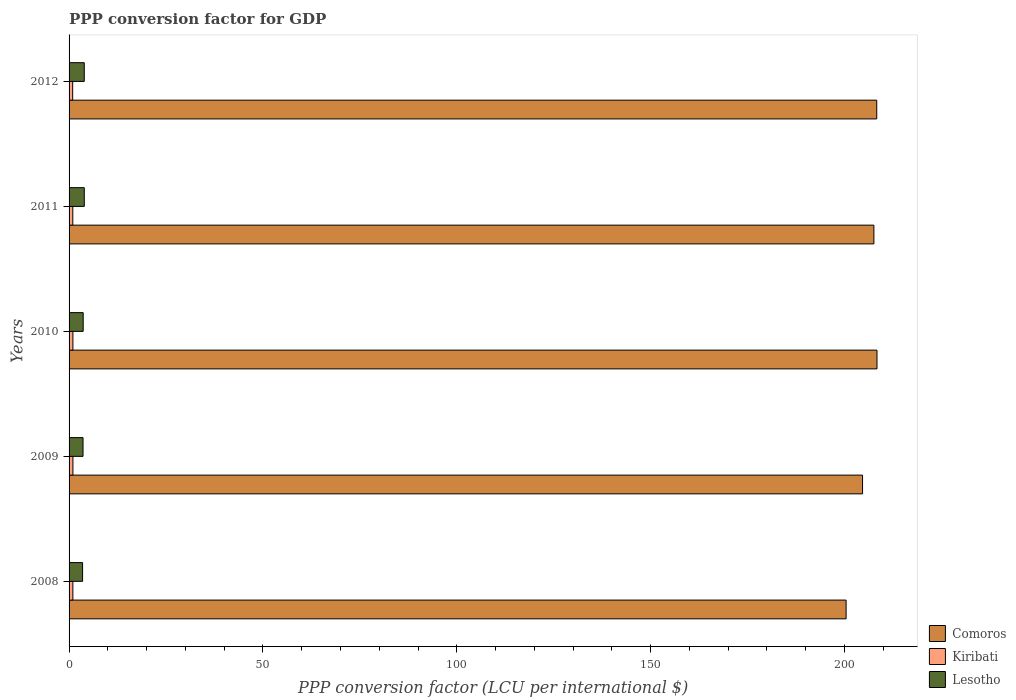How many different coloured bars are there?
Your response must be concise. 3. How many groups of bars are there?
Make the answer very short. 5. Are the number of bars per tick equal to the number of legend labels?
Ensure brevity in your answer.  Yes. Are the number of bars on each tick of the Y-axis equal?
Offer a very short reply. Yes. How many bars are there on the 4th tick from the top?
Offer a very short reply. 3. How many bars are there on the 4th tick from the bottom?
Offer a terse response. 3. What is the PPP conversion factor for GDP in Kiribati in 2010?
Provide a succinct answer. 0.99. Across all years, what is the maximum PPP conversion factor for GDP in Kiribati?
Offer a very short reply. 0.99. Across all years, what is the minimum PPP conversion factor for GDP in Comoros?
Offer a terse response. 200.42. What is the total PPP conversion factor for GDP in Kiribati in the graph?
Your answer should be compact. 4.85. What is the difference between the PPP conversion factor for GDP in Kiribati in 2009 and that in 2010?
Give a very brief answer. 0. What is the difference between the PPP conversion factor for GDP in Lesotho in 2010 and the PPP conversion factor for GDP in Comoros in 2011?
Your response must be concise. -203.94. What is the average PPP conversion factor for GDP in Comoros per year?
Your response must be concise. 205.87. In the year 2011, what is the difference between the PPP conversion factor for GDP in Comoros and PPP conversion factor for GDP in Lesotho?
Ensure brevity in your answer.  203.66. In how many years, is the PPP conversion factor for GDP in Lesotho greater than 100 LCU?
Ensure brevity in your answer.  0. What is the ratio of the PPP conversion factor for GDP in Lesotho in 2008 to that in 2009?
Offer a terse response. 0.97. Is the PPP conversion factor for GDP in Comoros in 2010 less than that in 2012?
Offer a very short reply. No. Is the difference between the PPP conversion factor for GDP in Comoros in 2008 and 2011 greater than the difference between the PPP conversion factor for GDP in Lesotho in 2008 and 2011?
Ensure brevity in your answer.  No. What is the difference between the highest and the second highest PPP conversion factor for GDP in Kiribati?
Offer a terse response. 0. What is the difference between the highest and the lowest PPP conversion factor for GDP in Kiribati?
Give a very brief answer. 0.06. Is the sum of the PPP conversion factor for GDP in Comoros in 2008 and 2011 greater than the maximum PPP conversion factor for GDP in Kiribati across all years?
Offer a very short reply. Yes. What does the 3rd bar from the top in 2009 represents?
Ensure brevity in your answer.  Comoros. What does the 2nd bar from the bottom in 2008 represents?
Provide a succinct answer. Kiribati. Is it the case that in every year, the sum of the PPP conversion factor for GDP in Lesotho and PPP conversion factor for GDP in Comoros is greater than the PPP conversion factor for GDP in Kiribati?
Provide a short and direct response. Yes. Are all the bars in the graph horizontal?
Offer a terse response. Yes. What is the difference between two consecutive major ticks on the X-axis?
Offer a terse response. 50. Where does the legend appear in the graph?
Your answer should be very brief. Bottom right. How are the legend labels stacked?
Give a very brief answer. Vertical. What is the title of the graph?
Provide a short and direct response. PPP conversion factor for GDP. Does "South Africa" appear as one of the legend labels in the graph?
Your answer should be very brief. No. What is the label or title of the X-axis?
Give a very brief answer. PPP conversion factor (LCU per international $). What is the PPP conversion factor (LCU per international $) of Comoros in 2008?
Provide a succinct answer. 200.42. What is the PPP conversion factor (LCU per international $) of Kiribati in 2008?
Your response must be concise. 0.98. What is the PPP conversion factor (LCU per international $) of Lesotho in 2008?
Provide a short and direct response. 3.48. What is the PPP conversion factor (LCU per international $) of Comoros in 2009?
Offer a very short reply. 204.66. What is the PPP conversion factor (LCU per international $) of Kiribati in 2009?
Your answer should be compact. 0.99. What is the PPP conversion factor (LCU per international $) in Lesotho in 2009?
Make the answer very short. 3.6. What is the PPP conversion factor (LCU per international $) of Comoros in 2010?
Your response must be concise. 208.39. What is the PPP conversion factor (LCU per international $) in Kiribati in 2010?
Make the answer very short. 0.99. What is the PPP conversion factor (LCU per international $) in Lesotho in 2010?
Your answer should be compact. 3.64. What is the PPP conversion factor (LCU per international $) in Comoros in 2011?
Your answer should be compact. 207.58. What is the PPP conversion factor (LCU per international $) in Kiribati in 2011?
Give a very brief answer. 0.96. What is the PPP conversion factor (LCU per international $) in Lesotho in 2011?
Give a very brief answer. 3.92. What is the PPP conversion factor (LCU per international $) in Comoros in 2012?
Give a very brief answer. 208.32. What is the PPP conversion factor (LCU per international $) of Kiribati in 2012?
Your response must be concise. 0.93. What is the PPP conversion factor (LCU per international $) of Lesotho in 2012?
Offer a very short reply. 3.92. Across all years, what is the maximum PPP conversion factor (LCU per international $) of Comoros?
Offer a terse response. 208.39. Across all years, what is the maximum PPP conversion factor (LCU per international $) of Kiribati?
Make the answer very short. 0.99. Across all years, what is the maximum PPP conversion factor (LCU per international $) of Lesotho?
Ensure brevity in your answer.  3.92. Across all years, what is the minimum PPP conversion factor (LCU per international $) of Comoros?
Your response must be concise. 200.42. Across all years, what is the minimum PPP conversion factor (LCU per international $) of Kiribati?
Give a very brief answer. 0.93. Across all years, what is the minimum PPP conversion factor (LCU per international $) of Lesotho?
Your answer should be very brief. 3.48. What is the total PPP conversion factor (LCU per international $) in Comoros in the graph?
Offer a terse response. 1029.37. What is the total PPP conversion factor (LCU per international $) in Kiribati in the graph?
Offer a very short reply. 4.85. What is the total PPP conversion factor (LCU per international $) in Lesotho in the graph?
Offer a very short reply. 18.57. What is the difference between the PPP conversion factor (LCU per international $) of Comoros in 2008 and that in 2009?
Give a very brief answer. -4.24. What is the difference between the PPP conversion factor (LCU per international $) of Kiribati in 2008 and that in 2009?
Provide a short and direct response. -0.01. What is the difference between the PPP conversion factor (LCU per international $) of Lesotho in 2008 and that in 2009?
Your answer should be very brief. -0.12. What is the difference between the PPP conversion factor (LCU per international $) in Comoros in 2008 and that in 2010?
Your answer should be very brief. -7.97. What is the difference between the PPP conversion factor (LCU per international $) of Kiribati in 2008 and that in 2010?
Ensure brevity in your answer.  -0.01. What is the difference between the PPP conversion factor (LCU per international $) in Lesotho in 2008 and that in 2010?
Your response must be concise. -0.16. What is the difference between the PPP conversion factor (LCU per international $) of Comoros in 2008 and that in 2011?
Your answer should be compact. -7.16. What is the difference between the PPP conversion factor (LCU per international $) of Kiribati in 2008 and that in 2011?
Provide a succinct answer. 0.02. What is the difference between the PPP conversion factor (LCU per international $) in Lesotho in 2008 and that in 2011?
Provide a short and direct response. -0.44. What is the difference between the PPP conversion factor (LCU per international $) in Comoros in 2008 and that in 2012?
Offer a terse response. -7.9. What is the difference between the PPP conversion factor (LCU per international $) in Kiribati in 2008 and that in 2012?
Keep it short and to the point. 0.05. What is the difference between the PPP conversion factor (LCU per international $) in Lesotho in 2008 and that in 2012?
Offer a very short reply. -0.44. What is the difference between the PPP conversion factor (LCU per international $) in Comoros in 2009 and that in 2010?
Your response must be concise. -3.73. What is the difference between the PPP conversion factor (LCU per international $) in Kiribati in 2009 and that in 2010?
Offer a terse response. 0. What is the difference between the PPP conversion factor (LCU per international $) in Lesotho in 2009 and that in 2010?
Ensure brevity in your answer.  -0.04. What is the difference between the PPP conversion factor (LCU per international $) in Comoros in 2009 and that in 2011?
Your response must be concise. -2.93. What is the difference between the PPP conversion factor (LCU per international $) of Kiribati in 2009 and that in 2011?
Your answer should be compact. 0.03. What is the difference between the PPP conversion factor (LCU per international $) in Lesotho in 2009 and that in 2011?
Provide a short and direct response. -0.32. What is the difference between the PPP conversion factor (LCU per international $) in Comoros in 2009 and that in 2012?
Give a very brief answer. -3.66. What is the difference between the PPP conversion factor (LCU per international $) in Kiribati in 2009 and that in 2012?
Keep it short and to the point. 0.06. What is the difference between the PPP conversion factor (LCU per international $) of Lesotho in 2009 and that in 2012?
Provide a succinct answer. -0.32. What is the difference between the PPP conversion factor (LCU per international $) of Comoros in 2010 and that in 2011?
Offer a very short reply. 0.8. What is the difference between the PPP conversion factor (LCU per international $) in Kiribati in 2010 and that in 2011?
Your answer should be very brief. 0.03. What is the difference between the PPP conversion factor (LCU per international $) in Lesotho in 2010 and that in 2011?
Offer a terse response. -0.28. What is the difference between the PPP conversion factor (LCU per international $) of Comoros in 2010 and that in 2012?
Give a very brief answer. 0.07. What is the difference between the PPP conversion factor (LCU per international $) in Kiribati in 2010 and that in 2012?
Your response must be concise. 0.06. What is the difference between the PPP conversion factor (LCU per international $) in Lesotho in 2010 and that in 2012?
Keep it short and to the point. -0.28. What is the difference between the PPP conversion factor (LCU per international $) of Comoros in 2011 and that in 2012?
Keep it short and to the point. -0.74. What is the difference between the PPP conversion factor (LCU per international $) of Kiribati in 2011 and that in 2012?
Offer a terse response. 0.03. What is the difference between the PPP conversion factor (LCU per international $) in Lesotho in 2011 and that in 2012?
Give a very brief answer. 0. What is the difference between the PPP conversion factor (LCU per international $) in Comoros in 2008 and the PPP conversion factor (LCU per international $) in Kiribati in 2009?
Offer a very short reply. 199.43. What is the difference between the PPP conversion factor (LCU per international $) in Comoros in 2008 and the PPP conversion factor (LCU per international $) in Lesotho in 2009?
Give a very brief answer. 196.82. What is the difference between the PPP conversion factor (LCU per international $) of Kiribati in 2008 and the PPP conversion factor (LCU per international $) of Lesotho in 2009?
Your answer should be compact. -2.62. What is the difference between the PPP conversion factor (LCU per international $) in Comoros in 2008 and the PPP conversion factor (LCU per international $) in Kiribati in 2010?
Give a very brief answer. 199.43. What is the difference between the PPP conversion factor (LCU per international $) of Comoros in 2008 and the PPP conversion factor (LCU per international $) of Lesotho in 2010?
Provide a succinct answer. 196.78. What is the difference between the PPP conversion factor (LCU per international $) in Kiribati in 2008 and the PPP conversion factor (LCU per international $) in Lesotho in 2010?
Your answer should be compact. -2.66. What is the difference between the PPP conversion factor (LCU per international $) in Comoros in 2008 and the PPP conversion factor (LCU per international $) in Kiribati in 2011?
Your response must be concise. 199.46. What is the difference between the PPP conversion factor (LCU per international $) in Comoros in 2008 and the PPP conversion factor (LCU per international $) in Lesotho in 2011?
Make the answer very short. 196.5. What is the difference between the PPP conversion factor (LCU per international $) of Kiribati in 2008 and the PPP conversion factor (LCU per international $) of Lesotho in 2011?
Make the answer very short. -2.94. What is the difference between the PPP conversion factor (LCU per international $) of Comoros in 2008 and the PPP conversion factor (LCU per international $) of Kiribati in 2012?
Offer a very short reply. 199.49. What is the difference between the PPP conversion factor (LCU per international $) of Comoros in 2008 and the PPP conversion factor (LCU per international $) of Lesotho in 2012?
Your answer should be compact. 196.5. What is the difference between the PPP conversion factor (LCU per international $) of Kiribati in 2008 and the PPP conversion factor (LCU per international $) of Lesotho in 2012?
Your response must be concise. -2.94. What is the difference between the PPP conversion factor (LCU per international $) in Comoros in 2009 and the PPP conversion factor (LCU per international $) in Kiribati in 2010?
Ensure brevity in your answer.  203.67. What is the difference between the PPP conversion factor (LCU per international $) in Comoros in 2009 and the PPP conversion factor (LCU per international $) in Lesotho in 2010?
Ensure brevity in your answer.  201.02. What is the difference between the PPP conversion factor (LCU per international $) in Kiribati in 2009 and the PPP conversion factor (LCU per international $) in Lesotho in 2010?
Offer a terse response. -2.65. What is the difference between the PPP conversion factor (LCU per international $) in Comoros in 2009 and the PPP conversion factor (LCU per international $) in Kiribati in 2011?
Your response must be concise. 203.7. What is the difference between the PPP conversion factor (LCU per international $) in Comoros in 2009 and the PPP conversion factor (LCU per international $) in Lesotho in 2011?
Provide a short and direct response. 200.73. What is the difference between the PPP conversion factor (LCU per international $) of Kiribati in 2009 and the PPP conversion factor (LCU per international $) of Lesotho in 2011?
Make the answer very short. -2.93. What is the difference between the PPP conversion factor (LCU per international $) in Comoros in 2009 and the PPP conversion factor (LCU per international $) in Kiribati in 2012?
Your response must be concise. 203.73. What is the difference between the PPP conversion factor (LCU per international $) in Comoros in 2009 and the PPP conversion factor (LCU per international $) in Lesotho in 2012?
Your answer should be compact. 200.74. What is the difference between the PPP conversion factor (LCU per international $) of Kiribati in 2009 and the PPP conversion factor (LCU per international $) of Lesotho in 2012?
Offer a very short reply. -2.93. What is the difference between the PPP conversion factor (LCU per international $) of Comoros in 2010 and the PPP conversion factor (LCU per international $) of Kiribati in 2011?
Your answer should be compact. 207.43. What is the difference between the PPP conversion factor (LCU per international $) of Comoros in 2010 and the PPP conversion factor (LCU per international $) of Lesotho in 2011?
Offer a very short reply. 204.46. What is the difference between the PPP conversion factor (LCU per international $) of Kiribati in 2010 and the PPP conversion factor (LCU per international $) of Lesotho in 2011?
Provide a short and direct response. -2.93. What is the difference between the PPP conversion factor (LCU per international $) of Comoros in 2010 and the PPP conversion factor (LCU per international $) of Kiribati in 2012?
Your answer should be very brief. 207.46. What is the difference between the PPP conversion factor (LCU per international $) in Comoros in 2010 and the PPP conversion factor (LCU per international $) in Lesotho in 2012?
Your answer should be very brief. 204.47. What is the difference between the PPP conversion factor (LCU per international $) in Kiribati in 2010 and the PPP conversion factor (LCU per international $) in Lesotho in 2012?
Give a very brief answer. -2.93. What is the difference between the PPP conversion factor (LCU per international $) of Comoros in 2011 and the PPP conversion factor (LCU per international $) of Kiribati in 2012?
Make the answer very short. 206.65. What is the difference between the PPP conversion factor (LCU per international $) of Comoros in 2011 and the PPP conversion factor (LCU per international $) of Lesotho in 2012?
Provide a succinct answer. 203.66. What is the difference between the PPP conversion factor (LCU per international $) in Kiribati in 2011 and the PPP conversion factor (LCU per international $) in Lesotho in 2012?
Offer a terse response. -2.96. What is the average PPP conversion factor (LCU per international $) in Comoros per year?
Provide a succinct answer. 205.87. What is the average PPP conversion factor (LCU per international $) of Kiribati per year?
Your response must be concise. 0.97. What is the average PPP conversion factor (LCU per international $) in Lesotho per year?
Keep it short and to the point. 3.71. In the year 2008, what is the difference between the PPP conversion factor (LCU per international $) of Comoros and PPP conversion factor (LCU per international $) of Kiribati?
Ensure brevity in your answer.  199.44. In the year 2008, what is the difference between the PPP conversion factor (LCU per international $) of Comoros and PPP conversion factor (LCU per international $) of Lesotho?
Ensure brevity in your answer.  196.94. In the year 2008, what is the difference between the PPP conversion factor (LCU per international $) of Kiribati and PPP conversion factor (LCU per international $) of Lesotho?
Your response must be concise. -2.5. In the year 2009, what is the difference between the PPP conversion factor (LCU per international $) in Comoros and PPP conversion factor (LCU per international $) in Kiribati?
Offer a terse response. 203.67. In the year 2009, what is the difference between the PPP conversion factor (LCU per international $) of Comoros and PPP conversion factor (LCU per international $) of Lesotho?
Offer a very short reply. 201.06. In the year 2009, what is the difference between the PPP conversion factor (LCU per international $) in Kiribati and PPP conversion factor (LCU per international $) in Lesotho?
Your answer should be compact. -2.61. In the year 2010, what is the difference between the PPP conversion factor (LCU per international $) of Comoros and PPP conversion factor (LCU per international $) of Kiribati?
Offer a very short reply. 207.4. In the year 2010, what is the difference between the PPP conversion factor (LCU per international $) of Comoros and PPP conversion factor (LCU per international $) of Lesotho?
Your answer should be compact. 204.75. In the year 2010, what is the difference between the PPP conversion factor (LCU per international $) in Kiribati and PPP conversion factor (LCU per international $) in Lesotho?
Make the answer very short. -2.65. In the year 2011, what is the difference between the PPP conversion factor (LCU per international $) of Comoros and PPP conversion factor (LCU per international $) of Kiribati?
Offer a terse response. 206.62. In the year 2011, what is the difference between the PPP conversion factor (LCU per international $) in Comoros and PPP conversion factor (LCU per international $) in Lesotho?
Offer a terse response. 203.66. In the year 2011, what is the difference between the PPP conversion factor (LCU per international $) in Kiribati and PPP conversion factor (LCU per international $) in Lesotho?
Ensure brevity in your answer.  -2.96. In the year 2012, what is the difference between the PPP conversion factor (LCU per international $) in Comoros and PPP conversion factor (LCU per international $) in Kiribati?
Your answer should be very brief. 207.39. In the year 2012, what is the difference between the PPP conversion factor (LCU per international $) in Comoros and PPP conversion factor (LCU per international $) in Lesotho?
Offer a terse response. 204.4. In the year 2012, what is the difference between the PPP conversion factor (LCU per international $) in Kiribati and PPP conversion factor (LCU per international $) in Lesotho?
Provide a short and direct response. -2.99. What is the ratio of the PPP conversion factor (LCU per international $) of Comoros in 2008 to that in 2009?
Your response must be concise. 0.98. What is the ratio of the PPP conversion factor (LCU per international $) of Kiribati in 2008 to that in 2009?
Provide a succinct answer. 0.99. What is the ratio of the PPP conversion factor (LCU per international $) of Lesotho in 2008 to that in 2009?
Offer a very short reply. 0.97. What is the ratio of the PPP conversion factor (LCU per international $) in Comoros in 2008 to that in 2010?
Ensure brevity in your answer.  0.96. What is the ratio of the PPP conversion factor (LCU per international $) in Kiribati in 2008 to that in 2010?
Offer a terse response. 0.99. What is the ratio of the PPP conversion factor (LCU per international $) of Lesotho in 2008 to that in 2010?
Give a very brief answer. 0.96. What is the ratio of the PPP conversion factor (LCU per international $) of Comoros in 2008 to that in 2011?
Provide a short and direct response. 0.97. What is the ratio of the PPP conversion factor (LCU per international $) of Kiribati in 2008 to that in 2011?
Provide a succinct answer. 1.02. What is the ratio of the PPP conversion factor (LCU per international $) in Lesotho in 2008 to that in 2011?
Provide a short and direct response. 0.89. What is the ratio of the PPP conversion factor (LCU per international $) in Comoros in 2008 to that in 2012?
Provide a succinct answer. 0.96. What is the ratio of the PPP conversion factor (LCU per international $) in Kiribati in 2008 to that in 2012?
Offer a terse response. 1.05. What is the ratio of the PPP conversion factor (LCU per international $) of Lesotho in 2008 to that in 2012?
Your answer should be compact. 0.89. What is the ratio of the PPP conversion factor (LCU per international $) in Comoros in 2009 to that in 2010?
Offer a very short reply. 0.98. What is the ratio of the PPP conversion factor (LCU per international $) in Lesotho in 2009 to that in 2010?
Ensure brevity in your answer.  0.99. What is the ratio of the PPP conversion factor (LCU per international $) in Comoros in 2009 to that in 2011?
Your response must be concise. 0.99. What is the ratio of the PPP conversion factor (LCU per international $) in Kiribati in 2009 to that in 2011?
Provide a short and direct response. 1.03. What is the ratio of the PPP conversion factor (LCU per international $) in Lesotho in 2009 to that in 2011?
Give a very brief answer. 0.92. What is the ratio of the PPP conversion factor (LCU per international $) in Comoros in 2009 to that in 2012?
Your response must be concise. 0.98. What is the ratio of the PPP conversion factor (LCU per international $) in Kiribati in 2009 to that in 2012?
Make the answer very short. 1.07. What is the ratio of the PPP conversion factor (LCU per international $) in Lesotho in 2009 to that in 2012?
Your answer should be very brief. 0.92. What is the ratio of the PPP conversion factor (LCU per international $) of Comoros in 2010 to that in 2011?
Give a very brief answer. 1. What is the ratio of the PPP conversion factor (LCU per international $) in Kiribati in 2010 to that in 2011?
Provide a succinct answer. 1.03. What is the ratio of the PPP conversion factor (LCU per international $) in Lesotho in 2010 to that in 2011?
Make the answer very short. 0.93. What is the ratio of the PPP conversion factor (LCU per international $) in Kiribati in 2010 to that in 2012?
Make the answer very short. 1.06. What is the ratio of the PPP conversion factor (LCU per international $) in Lesotho in 2010 to that in 2012?
Your answer should be very brief. 0.93. What is the ratio of the PPP conversion factor (LCU per international $) of Comoros in 2011 to that in 2012?
Give a very brief answer. 1. What is the ratio of the PPP conversion factor (LCU per international $) of Kiribati in 2011 to that in 2012?
Your answer should be very brief. 1.03. What is the ratio of the PPP conversion factor (LCU per international $) of Lesotho in 2011 to that in 2012?
Provide a short and direct response. 1. What is the difference between the highest and the second highest PPP conversion factor (LCU per international $) of Comoros?
Offer a terse response. 0.07. What is the difference between the highest and the second highest PPP conversion factor (LCU per international $) in Kiribati?
Your answer should be very brief. 0. What is the difference between the highest and the second highest PPP conversion factor (LCU per international $) in Lesotho?
Keep it short and to the point. 0. What is the difference between the highest and the lowest PPP conversion factor (LCU per international $) in Comoros?
Provide a short and direct response. 7.97. What is the difference between the highest and the lowest PPP conversion factor (LCU per international $) of Kiribati?
Provide a short and direct response. 0.06. What is the difference between the highest and the lowest PPP conversion factor (LCU per international $) in Lesotho?
Offer a very short reply. 0.44. 